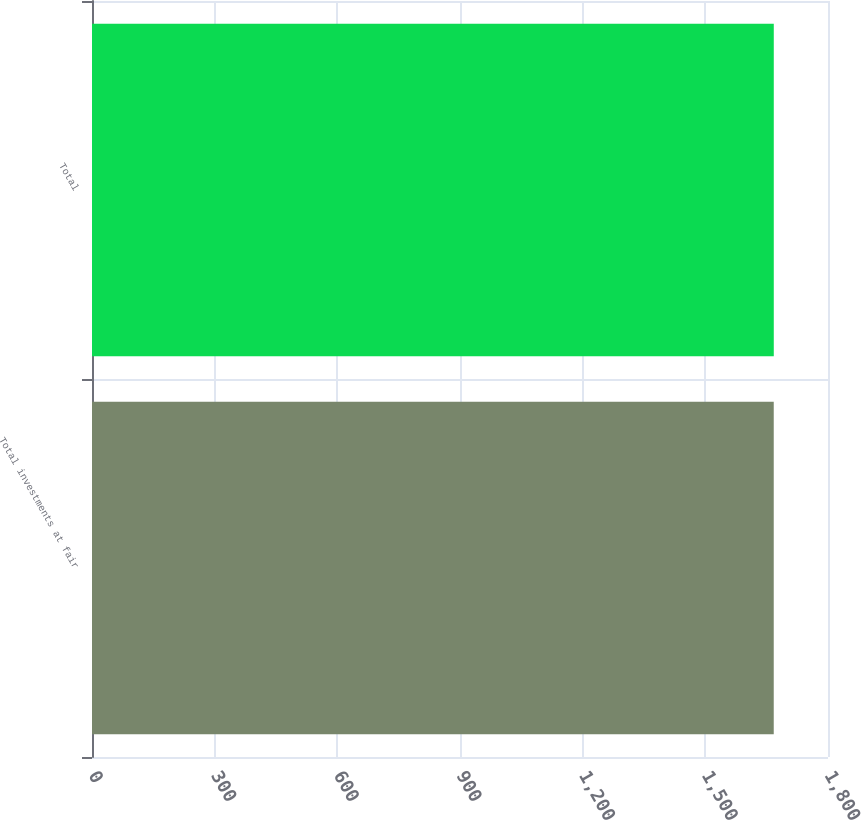Convert chart. <chart><loc_0><loc_0><loc_500><loc_500><bar_chart><fcel>Total investments at fair<fcel>Total<nl><fcel>1667.3<fcel>1667.4<nl></chart> 